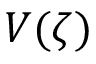<formula> <loc_0><loc_0><loc_500><loc_500>V ( \zeta )</formula> 